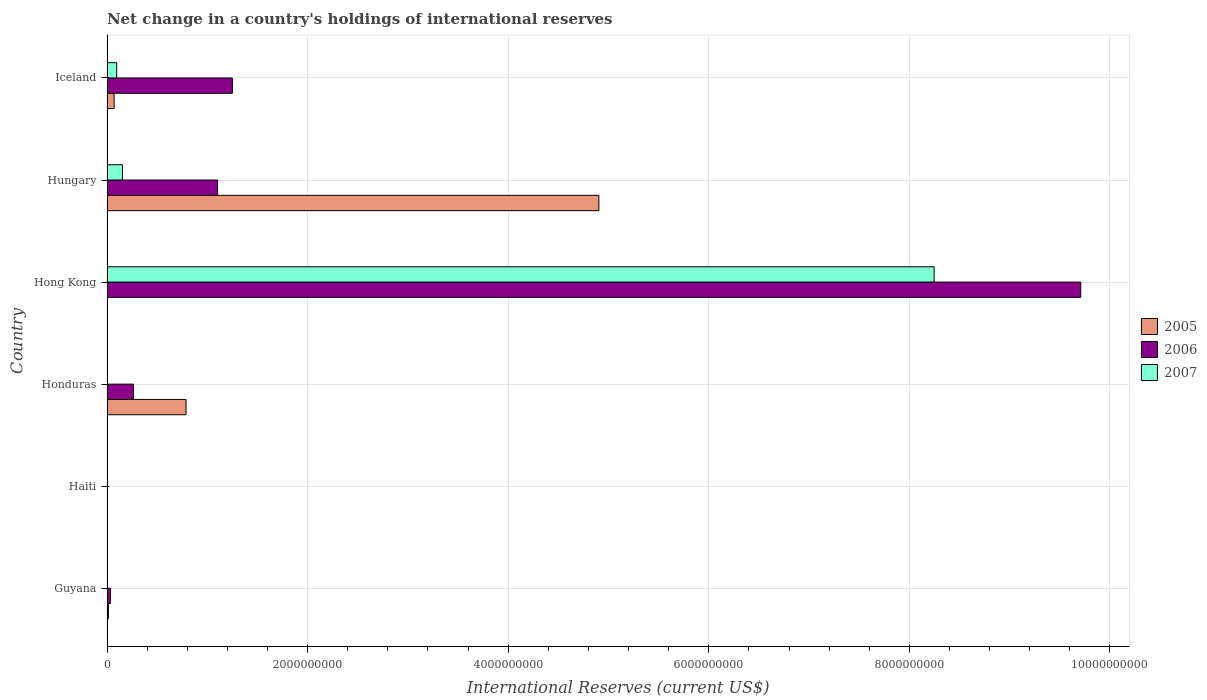How many different coloured bars are there?
Give a very brief answer. 3. How many bars are there on the 4th tick from the top?
Your response must be concise. 2. How many bars are there on the 2nd tick from the bottom?
Offer a terse response. 0. What is the label of the 1st group of bars from the top?
Your answer should be compact. Iceland. In how many cases, is the number of bars for a given country not equal to the number of legend labels?
Provide a succinct answer. 4. What is the international reserves in 2007 in Hong Kong?
Make the answer very short. 8.25e+09. Across all countries, what is the maximum international reserves in 2006?
Provide a succinct answer. 9.71e+09. In which country was the international reserves in 2007 maximum?
Your response must be concise. Hong Kong. What is the total international reserves in 2005 in the graph?
Offer a terse response. 5.78e+09. What is the difference between the international reserves in 2006 in Honduras and that in Hong Kong?
Your response must be concise. -9.45e+09. What is the difference between the international reserves in 2006 in Hong Kong and the international reserves in 2005 in Iceland?
Provide a short and direct response. 9.64e+09. What is the average international reserves in 2006 per country?
Offer a very short reply. 2.06e+09. What is the difference between the international reserves in 2007 and international reserves in 2006 in Hungary?
Ensure brevity in your answer.  -9.49e+08. In how many countries, is the international reserves in 2006 greater than 5200000000 US$?
Give a very brief answer. 1. What is the ratio of the international reserves in 2005 in Hungary to that in Iceland?
Your answer should be compact. 69.06. Is the international reserves in 2006 in Honduras less than that in Iceland?
Keep it short and to the point. Yes. What is the difference between the highest and the second highest international reserves in 2006?
Provide a short and direct response. 8.46e+09. What is the difference between the highest and the lowest international reserves in 2006?
Provide a succinct answer. 9.71e+09. In how many countries, is the international reserves in 2005 greater than the average international reserves in 2005 taken over all countries?
Make the answer very short. 1. Is the sum of the international reserves in 2005 in Honduras and Hungary greater than the maximum international reserves in 2006 across all countries?
Ensure brevity in your answer.  No. Are the values on the major ticks of X-axis written in scientific E-notation?
Your answer should be very brief. No. Does the graph contain any zero values?
Your answer should be very brief. Yes. Does the graph contain grids?
Your answer should be very brief. Yes. What is the title of the graph?
Provide a short and direct response. Net change in a country's holdings of international reserves. What is the label or title of the X-axis?
Keep it short and to the point. International Reserves (current US$). What is the International Reserves (current US$) of 2005 in Guyana?
Provide a short and direct response. 1.43e+07. What is the International Reserves (current US$) of 2006 in Guyana?
Your answer should be compact. 3.33e+07. What is the International Reserves (current US$) in 2005 in Haiti?
Give a very brief answer. 0. What is the International Reserves (current US$) of 2006 in Haiti?
Offer a terse response. 0. What is the International Reserves (current US$) in 2007 in Haiti?
Provide a succinct answer. 0. What is the International Reserves (current US$) in 2005 in Honduras?
Make the answer very short. 7.88e+08. What is the International Reserves (current US$) of 2006 in Honduras?
Offer a terse response. 2.63e+08. What is the International Reserves (current US$) of 2007 in Honduras?
Ensure brevity in your answer.  0. What is the International Reserves (current US$) of 2005 in Hong Kong?
Provide a succinct answer. 0. What is the International Reserves (current US$) of 2006 in Hong Kong?
Ensure brevity in your answer.  9.71e+09. What is the International Reserves (current US$) of 2007 in Hong Kong?
Offer a terse response. 8.25e+09. What is the International Reserves (current US$) in 2005 in Hungary?
Ensure brevity in your answer.  4.90e+09. What is the International Reserves (current US$) of 2006 in Hungary?
Offer a terse response. 1.10e+09. What is the International Reserves (current US$) in 2007 in Hungary?
Offer a terse response. 1.54e+08. What is the International Reserves (current US$) in 2005 in Iceland?
Keep it short and to the point. 7.10e+07. What is the International Reserves (current US$) in 2006 in Iceland?
Offer a very short reply. 1.25e+09. What is the International Reserves (current US$) of 2007 in Iceland?
Give a very brief answer. 9.67e+07. Across all countries, what is the maximum International Reserves (current US$) of 2005?
Your answer should be very brief. 4.90e+09. Across all countries, what is the maximum International Reserves (current US$) in 2006?
Provide a short and direct response. 9.71e+09. Across all countries, what is the maximum International Reserves (current US$) of 2007?
Your response must be concise. 8.25e+09. Across all countries, what is the minimum International Reserves (current US$) in 2007?
Offer a very short reply. 0. What is the total International Reserves (current US$) in 2005 in the graph?
Make the answer very short. 5.78e+09. What is the total International Reserves (current US$) of 2006 in the graph?
Provide a short and direct response. 1.24e+1. What is the total International Reserves (current US$) of 2007 in the graph?
Offer a terse response. 8.50e+09. What is the difference between the International Reserves (current US$) of 2005 in Guyana and that in Honduras?
Give a very brief answer. -7.74e+08. What is the difference between the International Reserves (current US$) in 2006 in Guyana and that in Honduras?
Provide a short and direct response. -2.30e+08. What is the difference between the International Reserves (current US$) of 2006 in Guyana and that in Hong Kong?
Your answer should be compact. -9.68e+09. What is the difference between the International Reserves (current US$) of 2005 in Guyana and that in Hungary?
Provide a succinct answer. -4.89e+09. What is the difference between the International Reserves (current US$) in 2006 in Guyana and that in Hungary?
Keep it short and to the point. -1.07e+09. What is the difference between the International Reserves (current US$) of 2005 in Guyana and that in Iceland?
Your answer should be very brief. -5.67e+07. What is the difference between the International Reserves (current US$) in 2006 in Guyana and that in Iceland?
Ensure brevity in your answer.  -1.22e+09. What is the difference between the International Reserves (current US$) of 2006 in Honduras and that in Hong Kong?
Make the answer very short. -9.45e+09. What is the difference between the International Reserves (current US$) of 2005 in Honduras and that in Hungary?
Your answer should be very brief. -4.12e+09. What is the difference between the International Reserves (current US$) in 2006 in Honduras and that in Hungary?
Keep it short and to the point. -8.39e+08. What is the difference between the International Reserves (current US$) of 2005 in Honduras and that in Iceland?
Give a very brief answer. 7.17e+08. What is the difference between the International Reserves (current US$) of 2006 in Honduras and that in Iceland?
Offer a very short reply. -9.87e+08. What is the difference between the International Reserves (current US$) of 2006 in Hong Kong and that in Hungary?
Make the answer very short. 8.61e+09. What is the difference between the International Reserves (current US$) of 2007 in Hong Kong and that in Hungary?
Your answer should be compact. 8.09e+09. What is the difference between the International Reserves (current US$) of 2006 in Hong Kong and that in Iceland?
Your response must be concise. 8.46e+09. What is the difference between the International Reserves (current US$) in 2007 in Hong Kong and that in Iceland?
Ensure brevity in your answer.  8.15e+09. What is the difference between the International Reserves (current US$) of 2005 in Hungary and that in Iceland?
Provide a succinct answer. 4.83e+09. What is the difference between the International Reserves (current US$) in 2006 in Hungary and that in Iceland?
Provide a succinct answer. -1.48e+08. What is the difference between the International Reserves (current US$) of 2007 in Hungary and that in Iceland?
Keep it short and to the point. 5.71e+07. What is the difference between the International Reserves (current US$) in 2005 in Guyana and the International Reserves (current US$) in 2006 in Honduras?
Your answer should be very brief. -2.49e+08. What is the difference between the International Reserves (current US$) in 2005 in Guyana and the International Reserves (current US$) in 2006 in Hong Kong?
Ensure brevity in your answer.  -9.69e+09. What is the difference between the International Reserves (current US$) of 2005 in Guyana and the International Reserves (current US$) of 2007 in Hong Kong?
Your response must be concise. -8.23e+09. What is the difference between the International Reserves (current US$) of 2006 in Guyana and the International Reserves (current US$) of 2007 in Hong Kong?
Your answer should be compact. -8.21e+09. What is the difference between the International Reserves (current US$) in 2005 in Guyana and the International Reserves (current US$) in 2006 in Hungary?
Keep it short and to the point. -1.09e+09. What is the difference between the International Reserves (current US$) in 2005 in Guyana and the International Reserves (current US$) in 2007 in Hungary?
Provide a succinct answer. -1.39e+08. What is the difference between the International Reserves (current US$) in 2006 in Guyana and the International Reserves (current US$) in 2007 in Hungary?
Your response must be concise. -1.20e+08. What is the difference between the International Reserves (current US$) in 2005 in Guyana and the International Reserves (current US$) in 2006 in Iceland?
Give a very brief answer. -1.24e+09. What is the difference between the International Reserves (current US$) in 2005 in Guyana and the International Reserves (current US$) in 2007 in Iceland?
Ensure brevity in your answer.  -8.24e+07. What is the difference between the International Reserves (current US$) in 2006 in Guyana and the International Reserves (current US$) in 2007 in Iceland?
Your answer should be compact. -6.34e+07. What is the difference between the International Reserves (current US$) in 2005 in Honduras and the International Reserves (current US$) in 2006 in Hong Kong?
Offer a terse response. -8.92e+09. What is the difference between the International Reserves (current US$) in 2005 in Honduras and the International Reserves (current US$) in 2007 in Hong Kong?
Provide a short and direct response. -7.46e+09. What is the difference between the International Reserves (current US$) in 2006 in Honduras and the International Reserves (current US$) in 2007 in Hong Kong?
Your answer should be compact. -7.98e+09. What is the difference between the International Reserves (current US$) of 2005 in Honduras and the International Reserves (current US$) of 2006 in Hungary?
Offer a terse response. -3.14e+08. What is the difference between the International Reserves (current US$) of 2005 in Honduras and the International Reserves (current US$) of 2007 in Hungary?
Make the answer very short. 6.34e+08. What is the difference between the International Reserves (current US$) of 2006 in Honduras and the International Reserves (current US$) of 2007 in Hungary?
Give a very brief answer. 1.09e+08. What is the difference between the International Reserves (current US$) of 2005 in Honduras and the International Reserves (current US$) of 2006 in Iceland?
Provide a short and direct response. -4.62e+08. What is the difference between the International Reserves (current US$) in 2005 in Honduras and the International Reserves (current US$) in 2007 in Iceland?
Your answer should be very brief. 6.91e+08. What is the difference between the International Reserves (current US$) of 2006 in Honduras and the International Reserves (current US$) of 2007 in Iceland?
Give a very brief answer. 1.66e+08. What is the difference between the International Reserves (current US$) of 2006 in Hong Kong and the International Reserves (current US$) of 2007 in Hungary?
Make the answer very short. 9.55e+09. What is the difference between the International Reserves (current US$) of 2006 in Hong Kong and the International Reserves (current US$) of 2007 in Iceland?
Ensure brevity in your answer.  9.61e+09. What is the difference between the International Reserves (current US$) of 2005 in Hungary and the International Reserves (current US$) of 2006 in Iceland?
Make the answer very short. 3.65e+09. What is the difference between the International Reserves (current US$) of 2005 in Hungary and the International Reserves (current US$) of 2007 in Iceland?
Make the answer very short. 4.81e+09. What is the difference between the International Reserves (current US$) of 2006 in Hungary and the International Reserves (current US$) of 2007 in Iceland?
Give a very brief answer. 1.01e+09. What is the average International Reserves (current US$) of 2005 per country?
Your answer should be very brief. 9.63e+08. What is the average International Reserves (current US$) of 2006 per country?
Keep it short and to the point. 2.06e+09. What is the average International Reserves (current US$) in 2007 per country?
Provide a succinct answer. 1.42e+09. What is the difference between the International Reserves (current US$) in 2005 and International Reserves (current US$) in 2006 in Guyana?
Make the answer very short. -1.90e+07. What is the difference between the International Reserves (current US$) in 2005 and International Reserves (current US$) in 2006 in Honduras?
Keep it short and to the point. 5.25e+08. What is the difference between the International Reserves (current US$) of 2006 and International Reserves (current US$) of 2007 in Hong Kong?
Ensure brevity in your answer.  1.46e+09. What is the difference between the International Reserves (current US$) in 2005 and International Reserves (current US$) in 2006 in Hungary?
Offer a very short reply. 3.80e+09. What is the difference between the International Reserves (current US$) in 2005 and International Reserves (current US$) in 2007 in Hungary?
Provide a succinct answer. 4.75e+09. What is the difference between the International Reserves (current US$) in 2006 and International Reserves (current US$) in 2007 in Hungary?
Give a very brief answer. 9.49e+08. What is the difference between the International Reserves (current US$) in 2005 and International Reserves (current US$) in 2006 in Iceland?
Give a very brief answer. -1.18e+09. What is the difference between the International Reserves (current US$) of 2005 and International Reserves (current US$) of 2007 in Iceland?
Your answer should be compact. -2.57e+07. What is the difference between the International Reserves (current US$) in 2006 and International Reserves (current US$) in 2007 in Iceland?
Make the answer very short. 1.15e+09. What is the ratio of the International Reserves (current US$) in 2005 in Guyana to that in Honduras?
Offer a very short reply. 0.02. What is the ratio of the International Reserves (current US$) in 2006 in Guyana to that in Honduras?
Your response must be concise. 0.13. What is the ratio of the International Reserves (current US$) of 2006 in Guyana to that in Hong Kong?
Your answer should be very brief. 0. What is the ratio of the International Reserves (current US$) of 2005 in Guyana to that in Hungary?
Your response must be concise. 0. What is the ratio of the International Reserves (current US$) of 2006 in Guyana to that in Hungary?
Make the answer very short. 0.03. What is the ratio of the International Reserves (current US$) of 2005 in Guyana to that in Iceland?
Offer a very short reply. 0.2. What is the ratio of the International Reserves (current US$) in 2006 in Guyana to that in Iceland?
Your answer should be very brief. 0.03. What is the ratio of the International Reserves (current US$) of 2006 in Honduras to that in Hong Kong?
Keep it short and to the point. 0.03. What is the ratio of the International Reserves (current US$) in 2005 in Honduras to that in Hungary?
Offer a terse response. 0.16. What is the ratio of the International Reserves (current US$) in 2006 in Honduras to that in Hungary?
Your response must be concise. 0.24. What is the ratio of the International Reserves (current US$) in 2005 in Honduras to that in Iceland?
Your response must be concise. 11.1. What is the ratio of the International Reserves (current US$) in 2006 in Honduras to that in Iceland?
Provide a succinct answer. 0.21. What is the ratio of the International Reserves (current US$) of 2006 in Hong Kong to that in Hungary?
Your answer should be very brief. 8.81. What is the ratio of the International Reserves (current US$) of 2007 in Hong Kong to that in Hungary?
Offer a terse response. 53.61. What is the ratio of the International Reserves (current US$) of 2006 in Hong Kong to that in Iceland?
Your answer should be compact. 7.77. What is the ratio of the International Reserves (current US$) of 2007 in Hong Kong to that in Iceland?
Offer a terse response. 85.27. What is the ratio of the International Reserves (current US$) in 2005 in Hungary to that in Iceland?
Offer a terse response. 69.06. What is the ratio of the International Reserves (current US$) of 2006 in Hungary to that in Iceland?
Keep it short and to the point. 0.88. What is the ratio of the International Reserves (current US$) in 2007 in Hungary to that in Iceland?
Ensure brevity in your answer.  1.59. What is the difference between the highest and the second highest International Reserves (current US$) in 2005?
Your response must be concise. 4.12e+09. What is the difference between the highest and the second highest International Reserves (current US$) in 2006?
Offer a terse response. 8.46e+09. What is the difference between the highest and the second highest International Reserves (current US$) of 2007?
Ensure brevity in your answer.  8.09e+09. What is the difference between the highest and the lowest International Reserves (current US$) of 2005?
Make the answer very short. 4.90e+09. What is the difference between the highest and the lowest International Reserves (current US$) in 2006?
Provide a succinct answer. 9.71e+09. What is the difference between the highest and the lowest International Reserves (current US$) in 2007?
Give a very brief answer. 8.25e+09. 